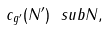<formula> <loc_0><loc_0><loc_500><loc_500>c _ { g ^ { \prime } } ( N ^ { \prime } ) \ s u b N ,</formula> 